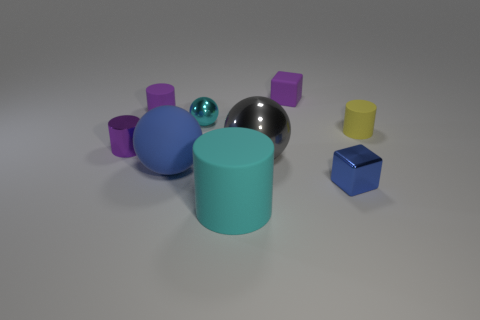What is the size of the ball that is the same color as the tiny metal cube?
Keep it short and to the point. Large. What number of other things are the same size as the gray shiny sphere?
Keep it short and to the point. 2. The matte thing that is on the right side of the purple thing behind the purple matte thing that is to the left of the big metal sphere is what color?
Provide a short and direct response. Yellow. There is a object that is both on the right side of the tiny matte cube and in front of the large metallic object; what is its shape?
Offer a terse response. Cube. How many other things are the same shape as the big cyan matte object?
Offer a very short reply. 3. There is a metal object behind the small shiny thing that is on the left side of the large matte thing behind the tiny blue metallic cube; what is its shape?
Ensure brevity in your answer.  Sphere. How many objects are either tiny blue shiny blocks or blue objects that are in front of the big metallic ball?
Ensure brevity in your answer.  2. Does the object that is on the right side of the blue metallic block have the same shape as the small shiny object that is on the right side of the big cyan object?
Offer a very short reply. No. How many things are either big cyan matte spheres or tiny rubber things?
Offer a terse response. 3. Is there a big gray cylinder?
Ensure brevity in your answer.  No. 